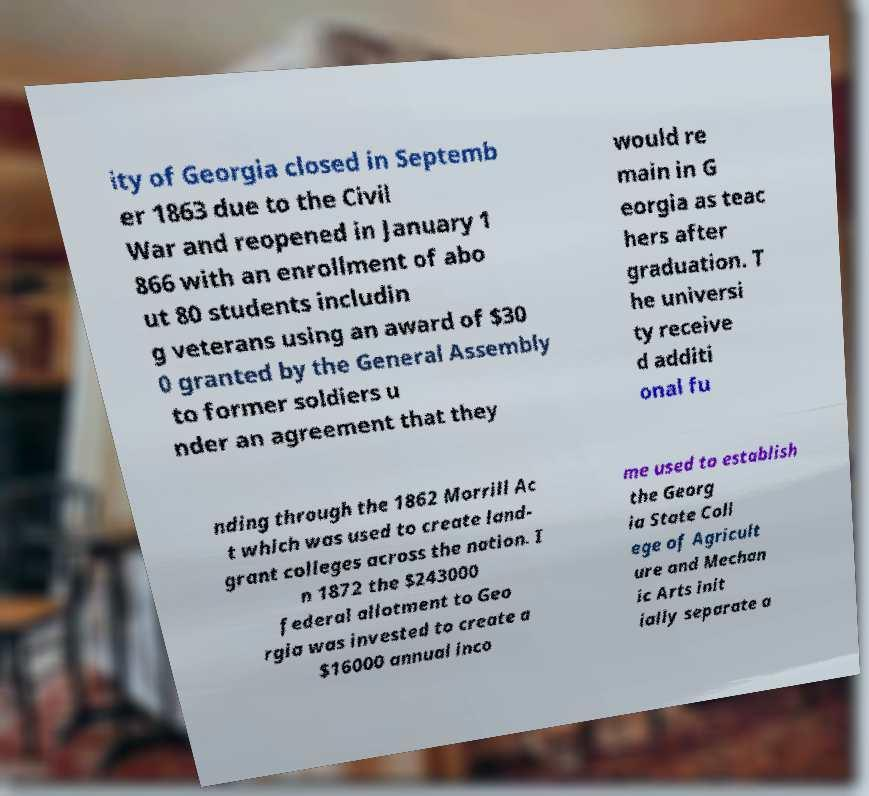Can you accurately transcribe the text from the provided image for me? ity of Georgia closed in Septemb er 1863 due to the Civil War and reopened in January 1 866 with an enrollment of abo ut 80 students includin g veterans using an award of $30 0 granted by the General Assembly to former soldiers u nder an agreement that they would re main in G eorgia as teac hers after graduation. T he universi ty receive d additi onal fu nding through the 1862 Morrill Ac t which was used to create land- grant colleges across the nation. I n 1872 the $243000 federal allotment to Geo rgia was invested to create a $16000 annual inco me used to establish the Georg ia State Coll ege of Agricult ure and Mechan ic Arts init ially separate a 